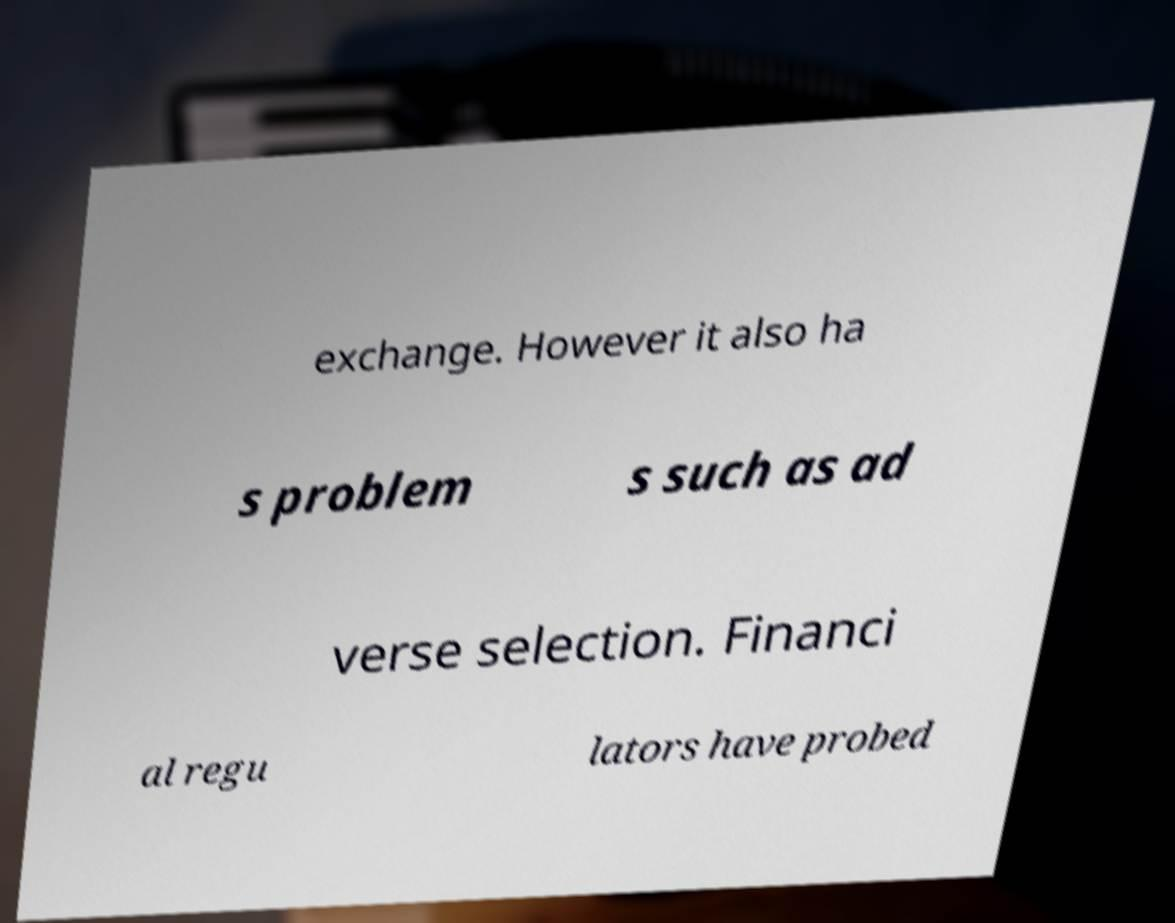Please identify and transcribe the text found in this image. exchange. However it also ha s problem s such as ad verse selection. Financi al regu lators have probed 